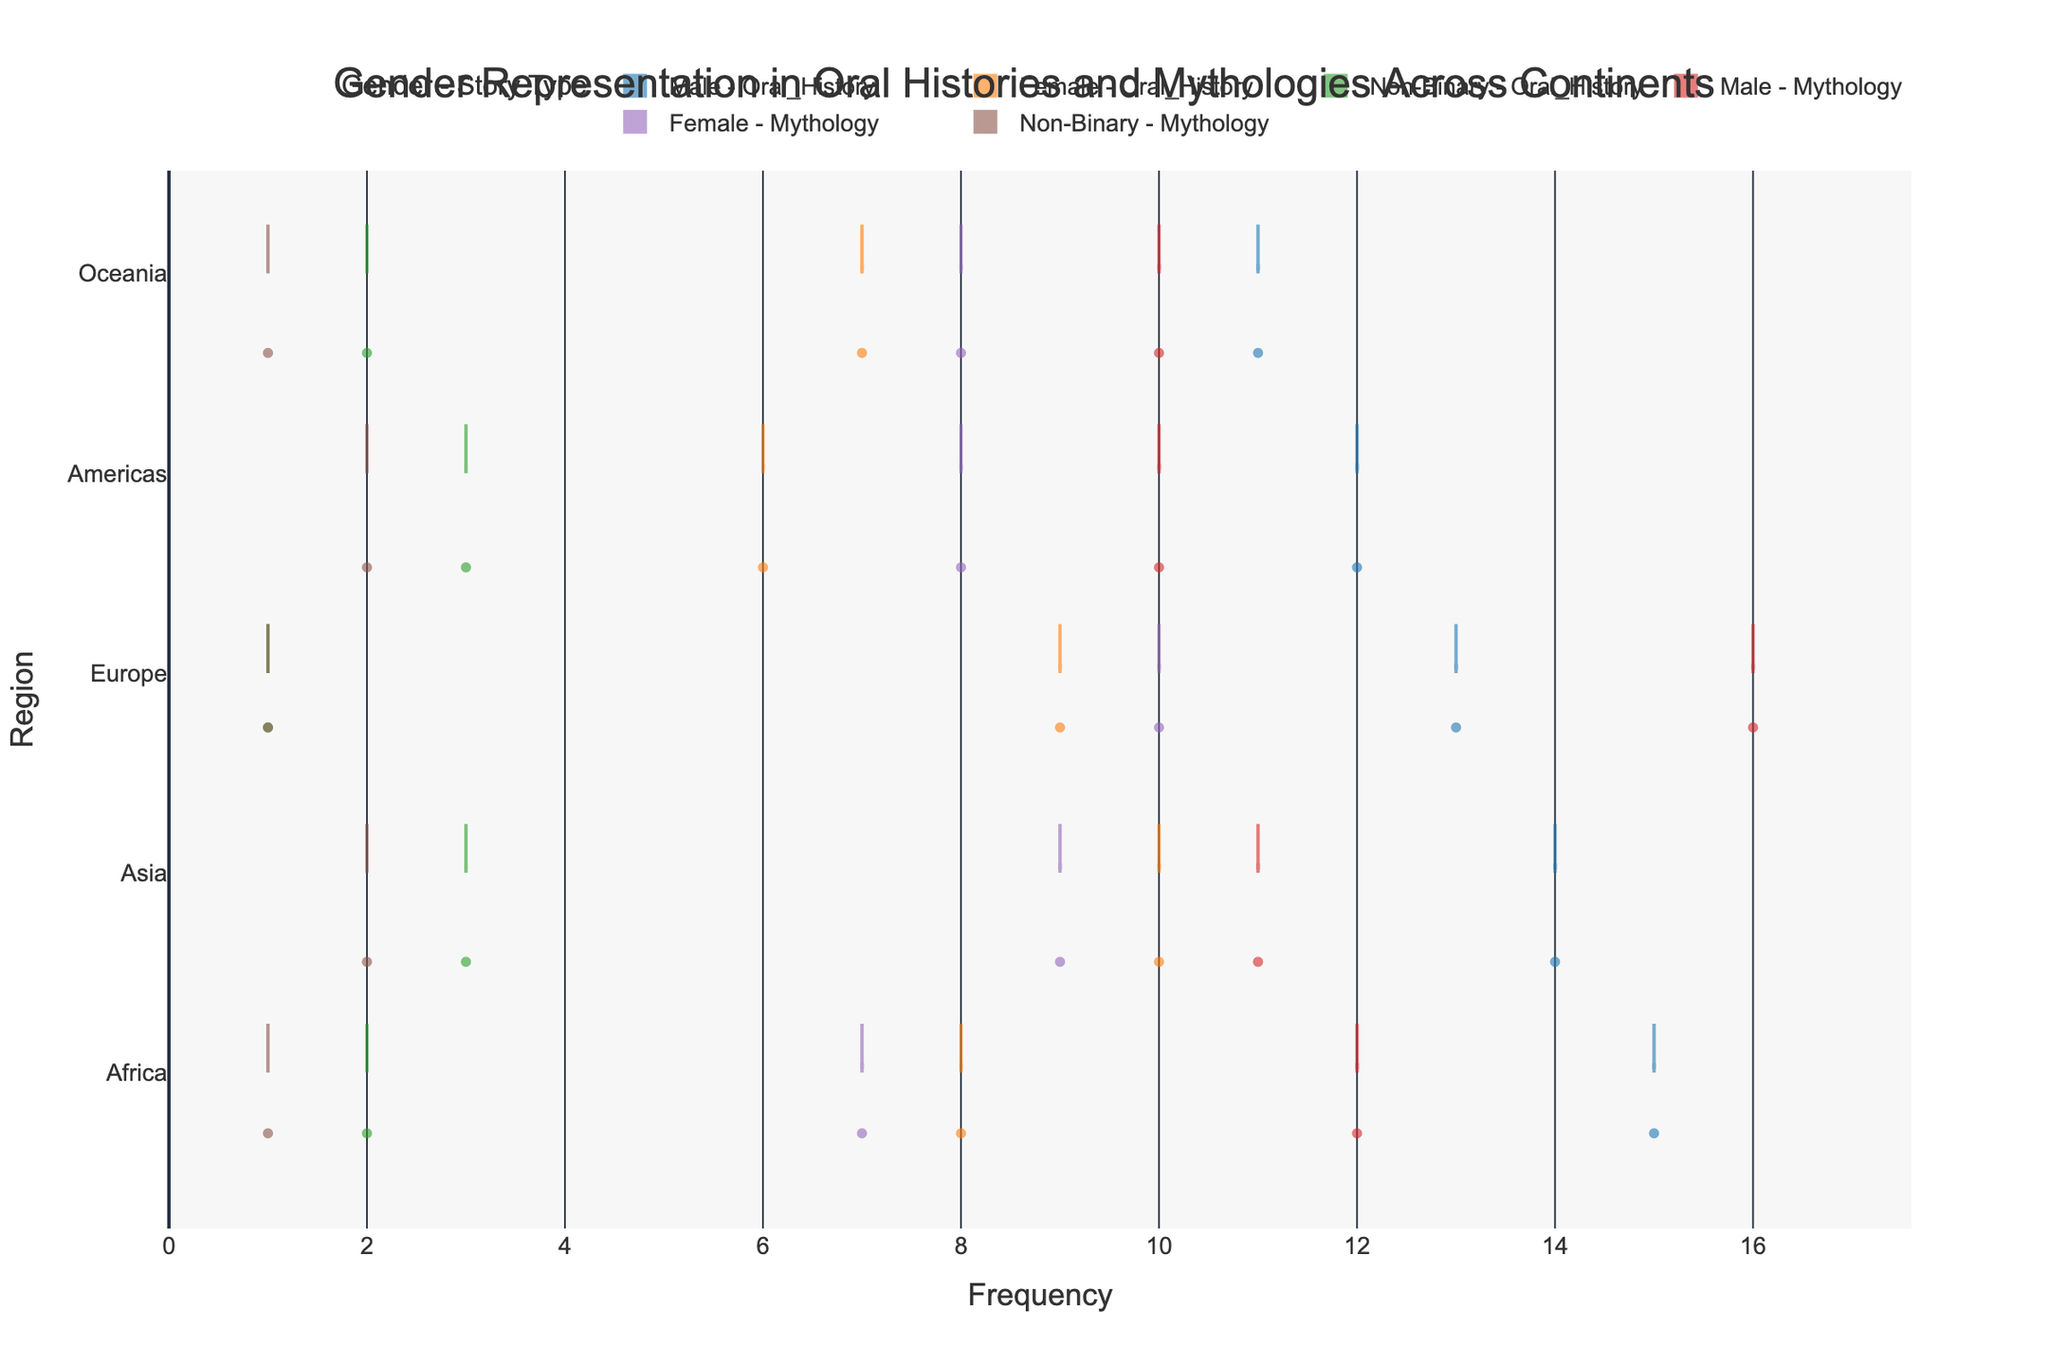What is the title of the figure? The title is at the top center of the figure. It reads: "Gender Representation in Oral Histories and Mythologies Across Continents".
Answer: Gender Representation in Oral Histories and Mythologies Across Continents Which gender and story type combination has the highest frequency in Europe? To find this, look at the Europe region and identify the highest outlier value (dot farthest to the right). The highest frequency is for "Male - Mythology" at 16.
Answer: Male - Mythology What region has the smallest range of frequency values for Oral Histories? Examine the length of the violin plots for the "Oral_History" story type across all regions. The Americas region has the smallest range for Oral Histories.
Answer: Americas How does the median frequency of Female characters in Mythology compare across different regions? Look at the horizontal line in the middle of the boxes within the "Female - Mythology" violins for each region. In Africa, it's at 7; in Asia, it's at 9; in Europe, it's at 10; in the Americas, it's at 8; in Oceania, it's at 8. The median for Europe is the highest.
Answer: Highest in Europe, lowest in Africa Which Gender-Story Type combination has the largest number of data points in Oceania? Count the individual points (dots) in the "Oceania" region. "Male - Oral_History" and "Male - Mythology" each have more points (11 and 10 respectively) than other combinations.
Answer: Male - Oral_History How many gender-story type combinations are shown for each continent? Count the distinct colors (representing gender-story type combinations) in each region. There are six different combinations per continent: Male - Oral_History, Female - Oral_History, Non-Binary - Oral_History, Male - Mythology, Female - Mythology, and Non-Binary - Mythology.
Answer: Six combinations per continent Compare the interquartile range (IQR) of Male characters in Oral Histories between Africa and Asia? The IQR is the width of the box in the plot. For Africa, the IQR is from 12 to 15 (width = 3). For Asia, the IQR is from 12 to 14 (width = 2). Africa has a larger IQR.
Answer: Larger in Africa Identify the Gender-Story Type combination with the lowest frequency in any continent. Look for the smallest value (dot closest to the left). Non-Binary - Oral_History and Non-Binary - Mythology combinations in Europe, Africa, and Oceania all have values of 1.
Answer: Non-Binary - Oral_History and Non-Binary - Mythology at 1 Is there a region where Female characters have a higher frequency in Mythology compared to Oral Histories? Compare the positions along the x-axis of the violin plots for "Female - Mythology" and "Female - Oral_History" in each region. In Asia and Europe, Female frequency in Mythology (9 and 10) is higher than in Oral Histories (10 and 9 respectively).
Answer: Yes, in Asia and Europe Which Gender-Story Type combination appears to be the most evenly distributed across continents? Look for the violin plot that has a similar spread and median across all regions. "Male - Oral_History" displays a consistent range across all regions.
Answer: Male - Oral_History 